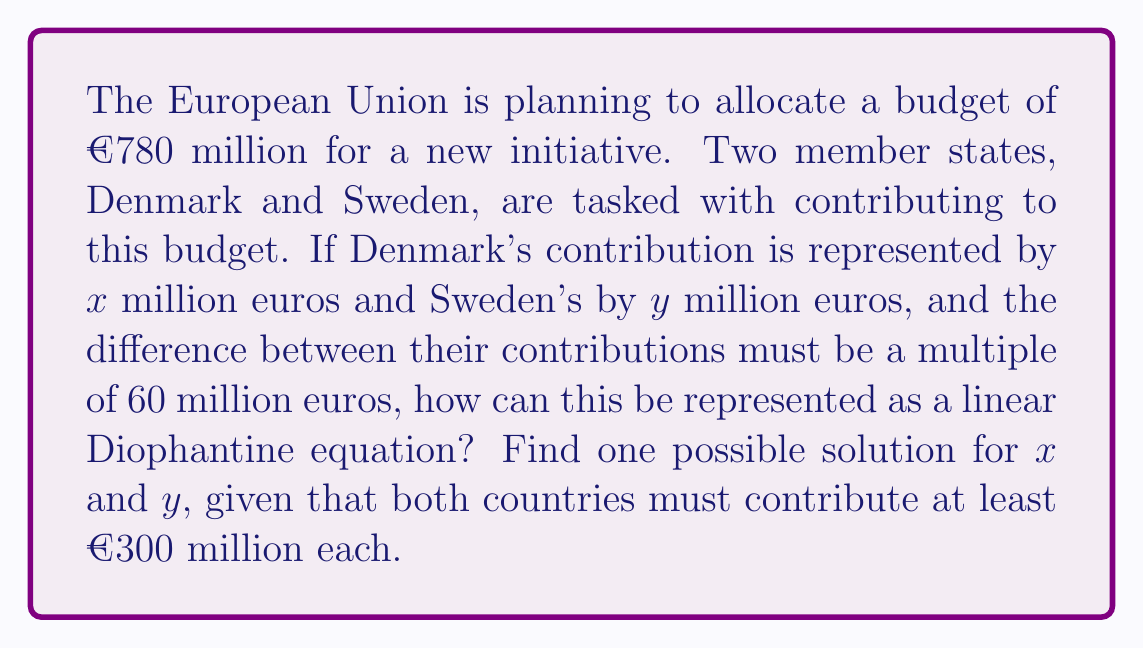Give your solution to this math problem. Let's approach this step-by-step:

1) First, we need to formulate the linear Diophantine equation. We know that:
   
   $x + y = 780$ (total budget)
   $x - y = 60k$ (difference is a multiple of 60), where $k$ is an integer

2) This gives us our linear Diophantine equation:

   $x - y = 60k$

3) We also know that $x + y = 780$. Let's use this to express $y$ in terms of $x$:

   $y = 780 - x$

4) Substituting this into our Diophantine equation:

   $x - (780 - x) = 60k$
   $2x - 780 = 60k$
   $2x = 60k + 780$
   $x = 30k + 390$

5) Now, $y = 780 - x = 780 - (30k + 390) = 390 - 30k$

6) We need to find a value for $k$ that satisfies $x \geq 300$ and $y \geq 300$:

   $x = 30k + 390 \geq 300$ is always true for non-negative $k$
   $y = 390 - 30k \geq 300$
   $90 \geq 30k$
   $3 \geq k$

7) The largest integer value of $k$ that satisfies this is 3. Let's use this:

   For $k = 3$:
   $x = 30(3) + 390 = 480$
   $y = 390 - 30(3) = 300$

8) We can verify:
   $480 + 300 = 780$ (correct total)
   $480 - 300 = 180$ (a multiple of 60)

Therefore, one possible solution is Denmark contributing €480 million and Sweden contributing €300 million.
Answer: One possible solution is $x = 480$ and $y = 300$, representing Denmark contributing €480 million and Sweden contributing €300 million to the EU budget initiative. 